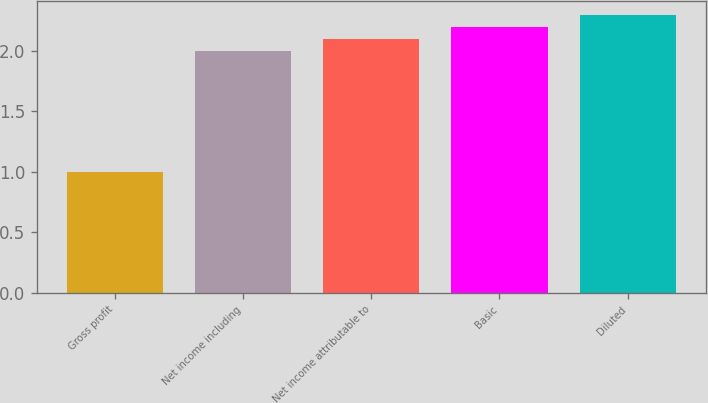Convert chart to OTSL. <chart><loc_0><loc_0><loc_500><loc_500><bar_chart><fcel>Gross profit<fcel>Net income including<fcel>Net income attributable to<fcel>Basic<fcel>Diluted<nl><fcel>1<fcel>2<fcel>2.1<fcel>2.2<fcel>2.3<nl></chart> 